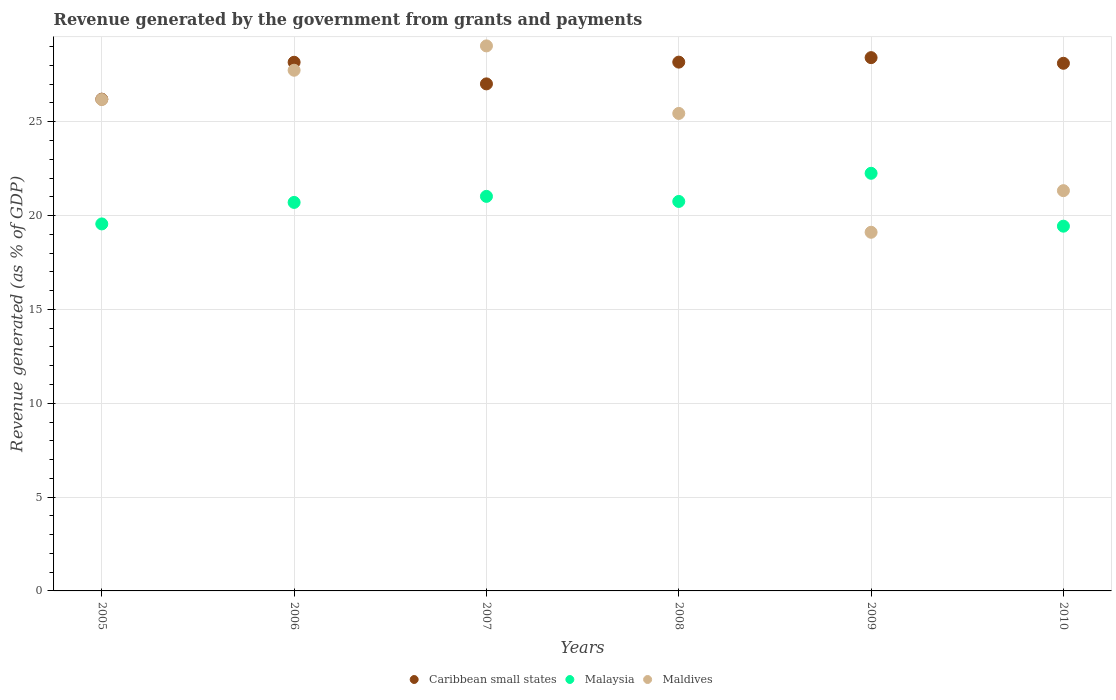How many different coloured dotlines are there?
Your response must be concise. 3. What is the revenue generated by the government in Maldives in 2005?
Provide a succinct answer. 26.19. Across all years, what is the maximum revenue generated by the government in Maldives?
Give a very brief answer. 29.04. Across all years, what is the minimum revenue generated by the government in Caribbean small states?
Make the answer very short. 26.2. In which year was the revenue generated by the government in Malaysia maximum?
Your answer should be very brief. 2009. In which year was the revenue generated by the government in Maldives minimum?
Your answer should be very brief. 2009. What is the total revenue generated by the government in Caribbean small states in the graph?
Offer a terse response. 166.1. What is the difference between the revenue generated by the government in Malaysia in 2006 and that in 2009?
Provide a short and direct response. -1.55. What is the difference between the revenue generated by the government in Maldives in 2010 and the revenue generated by the government in Malaysia in 2008?
Keep it short and to the point. 0.58. What is the average revenue generated by the government in Caribbean small states per year?
Keep it short and to the point. 27.68. In the year 2009, what is the difference between the revenue generated by the government in Maldives and revenue generated by the government in Malaysia?
Give a very brief answer. -3.14. In how many years, is the revenue generated by the government in Maldives greater than 3 %?
Your answer should be compact. 6. What is the ratio of the revenue generated by the government in Maldives in 2005 to that in 2009?
Ensure brevity in your answer.  1.37. Is the revenue generated by the government in Malaysia in 2005 less than that in 2008?
Ensure brevity in your answer.  Yes. Is the difference between the revenue generated by the government in Maldives in 2007 and 2009 greater than the difference between the revenue generated by the government in Malaysia in 2007 and 2009?
Offer a very short reply. Yes. What is the difference between the highest and the second highest revenue generated by the government in Maldives?
Provide a succinct answer. 1.3. What is the difference between the highest and the lowest revenue generated by the government in Caribbean small states?
Your response must be concise. 2.21. Is the sum of the revenue generated by the government in Maldives in 2006 and 2007 greater than the maximum revenue generated by the government in Malaysia across all years?
Make the answer very short. Yes. Is the revenue generated by the government in Caribbean small states strictly less than the revenue generated by the government in Maldives over the years?
Make the answer very short. No. How many dotlines are there?
Keep it short and to the point. 3. What is the difference between two consecutive major ticks on the Y-axis?
Provide a short and direct response. 5. Does the graph contain any zero values?
Ensure brevity in your answer.  No. How many legend labels are there?
Provide a succinct answer. 3. How are the legend labels stacked?
Your response must be concise. Horizontal. What is the title of the graph?
Provide a short and direct response. Revenue generated by the government from grants and payments. Does "Sri Lanka" appear as one of the legend labels in the graph?
Your answer should be very brief. No. What is the label or title of the X-axis?
Ensure brevity in your answer.  Years. What is the label or title of the Y-axis?
Keep it short and to the point. Revenue generated (as % of GDP). What is the Revenue generated (as % of GDP) in Caribbean small states in 2005?
Ensure brevity in your answer.  26.2. What is the Revenue generated (as % of GDP) in Malaysia in 2005?
Keep it short and to the point. 19.56. What is the Revenue generated (as % of GDP) in Maldives in 2005?
Your answer should be very brief. 26.19. What is the Revenue generated (as % of GDP) of Caribbean small states in 2006?
Offer a very short reply. 28.17. What is the Revenue generated (as % of GDP) in Malaysia in 2006?
Keep it short and to the point. 20.7. What is the Revenue generated (as % of GDP) of Maldives in 2006?
Ensure brevity in your answer.  27.75. What is the Revenue generated (as % of GDP) of Caribbean small states in 2007?
Keep it short and to the point. 27.02. What is the Revenue generated (as % of GDP) of Malaysia in 2007?
Offer a terse response. 21.02. What is the Revenue generated (as % of GDP) in Maldives in 2007?
Offer a very short reply. 29.04. What is the Revenue generated (as % of GDP) in Caribbean small states in 2008?
Your answer should be compact. 28.18. What is the Revenue generated (as % of GDP) in Malaysia in 2008?
Keep it short and to the point. 20.75. What is the Revenue generated (as % of GDP) of Maldives in 2008?
Make the answer very short. 25.44. What is the Revenue generated (as % of GDP) in Caribbean small states in 2009?
Your answer should be compact. 28.42. What is the Revenue generated (as % of GDP) of Malaysia in 2009?
Provide a succinct answer. 22.25. What is the Revenue generated (as % of GDP) in Maldives in 2009?
Give a very brief answer. 19.11. What is the Revenue generated (as % of GDP) in Caribbean small states in 2010?
Give a very brief answer. 28.12. What is the Revenue generated (as % of GDP) of Malaysia in 2010?
Your answer should be compact. 19.44. What is the Revenue generated (as % of GDP) of Maldives in 2010?
Offer a very short reply. 21.33. Across all years, what is the maximum Revenue generated (as % of GDP) in Caribbean small states?
Your response must be concise. 28.42. Across all years, what is the maximum Revenue generated (as % of GDP) in Malaysia?
Provide a succinct answer. 22.25. Across all years, what is the maximum Revenue generated (as % of GDP) in Maldives?
Keep it short and to the point. 29.04. Across all years, what is the minimum Revenue generated (as % of GDP) in Caribbean small states?
Offer a very short reply. 26.2. Across all years, what is the minimum Revenue generated (as % of GDP) of Malaysia?
Ensure brevity in your answer.  19.44. Across all years, what is the minimum Revenue generated (as % of GDP) of Maldives?
Keep it short and to the point. 19.11. What is the total Revenue generated (as % of GDP) of Caribbean small states in the graph?
Offer a very short reply. 166.1. What is the total Revenue generated (as % of GDP) of Malaysia in the graph?
Provide a short and direct response. 123.73. What is the total Revenue generated (as % of GDP) in Maldives in the graph?
Your answer should be very brief. 148.86. What is the difference between the Revenue generated (as % of GDP) of Caribbean small states in 2005 and that in 2006?
Ensure brevity in your answer.  -1.97. What is the difference between the Revenue generated (as % of GDP) in Malaysia in 2005 and that in 2006?
Offer a very short reply. -1.15. What is the difference between the Revenue generated (as % of GDP) of Maldives in 2005 and that in 2006?
Provide a succinct answer. -1.56. What is the difference between the Revenue generated (as % of GDP) in Caribbean small states in 2005 and that in 2007?
Offer a very short reply. -0.81. What is the difference between the Revenue generated (as % of GDP) of Malaysia in 2005 and that in 2007?
Provide a succinct answer. -1.47. What is the difference between the Revenue generated (as % of GDP) of Maldives in 2005 and that in 2007?
Make the answer very short. -2.86. What is the difference between the Revenue generated (as % of GDP) in Caribbean small states in 2005 and that in 2008?
Offer a very short reply. -1.97. What is the difference between the Revenue generated (as % of GDP) of Malaysia in 2005 and that in 2008?
Offer a very short reply. -1.2. What is the difference between the Revenue generated (as % of GDP) of Maldives in 2005 and that in 2008?
Make the answer very short. 0.74. What is the difference between the Revenue generated (as % of GDP) of Caribbean small states in 2005 and that in 2009?
Offer a very short reply. -2.21. What is the difference between the Revenue generated (as % of GDP) in Malaysia in 2005 and that in 2009?
Offer a terse response. -2.7. What is the difference between the Revenue generated (as % of GDP) in Maldives in 2005 and that in 2009?
Offer a terse response. 7.07. What is the difference between the Revenue generated (as % of GDP) of Caribbean small states in 2005 and that in 2010?
Provide a succinct answer. -1.91. What is the difference between the Revenue generated (as % of GDP) of Malaysia in 2005 and that in 2010?
Your response must be concise. 0.12. What is the difference between the Revenue generated (as % of GDP) in Maldives in 2005 and that in 2010?
Keep it short and to the point. 4.86. What is the difference between the Revenue generated (as % of GDP) of Caribbean small states in 2006 and that in 2007?
Make the answer very short. 1.15. What is the difference between the Revenue generated (as % of GDP) of Malaysia in 2006 and that in 2007?
Ensure brevity in your answer.  -0.32. What is the difference between the Revenue generated (as % of GDP) of Maldives in 2006 and that in 2007?
Ensure brevity in your answer.  -1.3. What is the difference between the Revenue generated (as % of GDP) in Caribbean small states in 2006 and that in 2008?
Your answer should be compact. -0.01. What is the difference between the Revenue generated (as % of GDP) in Malaysia in 2006 and that in 2008?
Ensure brevity in your answer.  -0.05. What is the difference between the Revenue generated (as % of GDP) of Maldives in 2006 and that in 2008?
Make the answer very short. 2.3. What is the difference between the Revenue generated (as % of GDP) in Caribbean small states in 2006 and that in 2009?
Offer a terse response. -0.25. What is the difference between the Revenue generated (as % of GDP) in Malaysia in 2006 and that in 2009?
Provide a short and direct response. -1.55. What is the difference between the Revenue generated (as % of GDP) in Maldives in 2006 and that in 2009?
Ensure brevity in your answer.  8.63. What is the difference between the Revenue generated (as % of GDP) in Caribbean small states in 2006 and that in 2010?
Your answer should be very brief. 0.05. What is the difference between the Revenue generated (as % of GDP) of Malaysia in 2006 and that in 2010?
Provide a short and direct response. 1.27. What is the difference between the Revenue generated (as % of GDP) in Maldives in 2006 and that in 2010?
Your answer should be compact. 6.42. What is the difference between the Revenue generated (as % of GDP) in Caribbean small states in 2007 and that in 2008?
Your response must be concise. -1.16. What is the difference between the Revenue generated (as % of GDP) of Malaysia in 2007 and that in 2008?
Ensure brevity in your answer.  0.27. What is the difference between the Revenue generated (as % of GDP) of Maldives in 2007 and that in 2008?
Your answer should be compact. 3.6. What is the difference between the Revenue generated (as % of GDP) in Caribbean small states in 2007 and that in 2009?
Provide a succinct answer. -1.4. What is the difference between the Revenue generated (as % of GDP) of Malaysia in 2007 and that in 2009?
Ensure brevity in your answer.  -1.23. What is the difference between the Revenue generated (as % of GDP) of Maldives in 2007 and that in 2009?
Offer a terse response. 9.93. What is the difference between the Revenue generated (as % of GDP) in Caribbean small states in 2007 and that in 2010?
Your response must be concise. -1.1. What is the difference between the Revenue generated (as % of GDP) of Malaysia in 2007 and that in 2010?
Your answer should be very brief. 1.59. What is the difference between the Revenue generated (as % of GDP) of Maldives in 2007 and that in 2010?
Provide a short and direct response. 7.71. What is the difference between the Revenue generated (as % of GDP) of Caribbean small states in 2008 and that in 2009?
Provide a succinct answer. -0.24. What is the difference between the Revenue generated (as % of GDP) of Malaysia in 2008 and that in 2009?
Your answer should be compact. -1.5. What is the difference between the Revenue generated (as % of GDP) in Maldives in 2008 and that in 2009?
Your answer should be compact. 6.33. What is the difference between the Revenue generated (as % of GDP) of Caribbean small states in 2008 and that in 2010?
Your answer should be compact. 0.06. What is the difference between the Revenue generated (as % of GDP) in Malaysia in 2008 and that in 2010?
Your response must be concise. 1.32. What is the difference between the Revenue generated (as % of GDP) of Maldives in 2008 and that in 2010?
Provide a succinct answer. 4.12. What is the difference between the Revenue generated (as % of GDP) of Caribbean small states in 2009 and that in 2010?
Offer a terse response. 0.3. What is the difference between the Revenue generated (as % of GDP) of Malaysia in 2009 and that in 2010?
Offer a terse response. 2.82. What is the difference between the Revenue generated (as % of GDP) of Maldives in 2009 and that in 2010?
Provide a short and direct response. -2.22. What is the difference between the Revenue generated (as % of GDP) of Caribbean small states in 2005 and the Revenue generated (as % of GDP) of Malaysia in 2006?
Keep it short and to the point. 5.5. What is the difference between the Revenue generated (as % of GDP) of Caribbean small states in 2005 and the Revenue generated (as % of GDP) of Maldives in 2006?
Offer a very short reply. -1.54. What is the difference between the Revenue generated (as % of GDP) of Malaysia in 2005 and the Revenue generated (as % of GDP) of Maldives in 2006?
Your response must be concise. -8.19. What is the difference between the Revenue generated (as % of GDP) in Caribbean small states in 2005 and the Revenue generated (as % of GDP) in Malaysia in 2007?
Keep it short and to the point. 5.18. What is the difference between the Revenue generated (as % of GDP) in Caribbean small states in 2005 and the Revenue generated (as % of GDP) in Maldives in 2007?
Your response must be concise. -2.84. What is the difference between the Revenue generated (as % of GDP) of Malaysia in 2005 and the Revenue generated (as % of GDP) of Maldives in 2007?
Your answer should be very brief. -9.49. What is the difference between the Revenue generated (as % of GDP) of Caribbean small states in 2005 and the Revenue generated (as % of GDP) of Malaysia in 2008?
Give a very brief answer. 5.45. What is the difference between the Revenue generated (as % of GDP) of Caribbean small states in 2005 and the Revenue generated (as % of GDP) of Maldives in 2008?
Make the answer very short. 0.76. What is the difference between the Revenue generated (as % of GDP) in Malaysia in 2005 and the Revenue generated (as % of GDP) in Maldives in 2008?
Offer a very short reply. -5.89. What is the difference between the Revenue generated (as % of GDP) of Caribbean small states in 2005 and the Revenue generated (as % of GDP) of Malaysia in 2009?
Offer a terse response. 3.95. What is the difference between the Revenue generated (as % of GDP) of Caribbean small states in 2005 and the Revenue generated (as % of GDP) of Maldives in 2009?
Offer a terse response. 7.09. What is the difference between the Revenue generated (as % of GDP) of Malaysia in 2005 and the Revenue generated (as % of GDP) of Maldives in 2009?
Offer a very short reply. 0.44. What is the difference between the Revenue generated (as % of GDP) in Caribbean small states in 2005 and the Revenue generated (as % of GDP) in Malaysia in 2010?
Make the answer very short. 6.77. What is the difference between the Revenue generated (as % of GDP) in Caribbean small states in 2005 and the Revenue generated (as % of GDP) in Maldives in 2010?
Ensure brevity in your answer.  4.88. What is the difference between the Revenue generated (as % of GDP) of Malaysia in 2005 and the Revenue generated (as % of GDP) of Maldives in 2010?
Your answer should be very brief. -1.77. What is the difference between the Revenue generated (as % of GDP) of Caribbean small states in 2006 and the Revenue generated (as % of GDP) of Malaysia in 2007?
Provide a short and direct response. 7.15. What is the difference between the Revenue generated (as % of GDP) in Caribbean small states in 2006 and the Revenue generated (as % of GDP) in Maldives in 2007?
Make the answer very short. -0.87. What is the difference between the Revenue generated (as % of GDP) in Malaysia in 2006 and the Revenue generated (as % of GDP) in Maldives in 2007?
Provide a succinct answer. -8.34. What is the difference between the Revenue generated (as % of GDP) in Caribbean small states in 2006 and the Revenue generated (as % of GDP) in Malaysia in 2008?
Keep it short and to the point. 7.42. What is the difference between the Revenue generated (as % of GDP) of Caribbean small states in 2006 and the Revenue generated (as % of GDP) of Maldives in 2008?
Ensure brevity in your answer.  2.73. What is the difference between the Revenue generated (as % of GDP) of Malaysia in 2006 and the Revenue generated (as % of GDP) of Maldives in 2008?
Give a very brief answer. -4.74. What is the difference between the Revenue generated (as % of GDP) of Caribbean small states in 2006 and the Revenue generated (as % of GDP) of Malaysia in 2009?
Your answer should be very brief. 5.92. What is the difference between the Revenue generated (as % of GDP) of Caribbean small states in 2006 and the Revenue generated (as % of GDP) of Maldives in 2009?
Keep it short and to the point. 9.06. What is the difference between the Revenue generated (as % of GDP) of Malaysia in 2006 and the Revenue generated (as % of GDP) of Maldives in 2009?
Your answer should be very brief. 1.59. What is the difference between the Revenue generated (as % of GDP) in Caribbean small states in 2006 and the Revenue generated (as % of GDP) in Malaysia in 2010?
Your answer should be very brief. 8.73. What is the difference between the Revenue generated (as % of GDP) in Caribbean small states in 2006 and the Revenue generated (as % of GDP) in Maldives in 2010?
Keep it short and to the point. 6.84. What is the difference between the Revenue generated (as % of GDP) in Malaysia in 2006 and the Revenue generated (as % of GDP) in Maldives in 2010?
Offer a very short reply. -0.63. What is the difference between the Revenue generated (as % of GDP) in Caribbean small states in 2007 and the Revenue generated (as % of GDP) in Malaysia in 2008?
Your response must be concise. 6.26. What is the difference between the Revenue generated (as % of GDP) of Caribbean small states in 2007 and the Revenue generated (as % of GDP) of Maldives in 2008?
Offer a very short reply. 1.57. What is the difference between the Revenue generated (as % of GDP) of Malaysia in 2007 and the Revenue generated (as % of GDP) of Maldives in 2008?
Provide a short and direct response. -4.42. What is the difference between the Revenue generated (as % of GDP) in Caribbean small states in 2007 and the Revenue generated (as % of GDP) in Malaysia in 2009?
Make the answer very short. 4.76. What is the difference between the Revenue generated (as % of GDP) of Caribbean small states in 2007 and the Revenue generated (as % of GDP) of Maldives in 2009?
Provide a short and direct response. 7.91. What is the difference between the Revenue generated (as % of GDP) in Malaysia in 2007 and the Revenue generated (as % of GDP) in Maldives in 2009?
Ensure brevity in your answer.  1.91. What is the difference between the Revenue generated (as % of GDP) in Caribbean small states in 2007 and the Revenue generated (as % of GDP) in Malaysia in 2010?
Keep it short and to the point. 7.58. What is the difference between the Revenue generated (as % of GDP) of Caribbean small states in 2007 and the Revenue generated (as % of GDP) of Maldives in 2010?
Ensure brevity in your answer.  5.69. What is the difference between the Revenue generated (as % of GDP) of Malaysia in 2007 and the Revenue generated (as % of GDP) of Maldives in 2010?
Offer a very short reply. -0.3. What is the difference between the Revenue generated (as % of GDP) in Caribbean small states in 2008 and the Revenue generated (as % of GDP) in Malaysia in 2009?
Offer a very short reply. 5.92. What is the difference between the Revenue generated (as % of GDP) of Caribbean small states in 2008 and the Revenue generated (as % of GDP) of Maldives in 2009?
Offer a very short reply. 9.07. What is the difference between the Revenue generated (as % of GDP) in Malaysia in 2008 and the Revenue generated (as % of GDP) in Maldives in 2009?
Offer a very short reply. 1.64. What is the difference between the Revenue generated (as % of GDP) in Caribbean small states in 2008 and the Revenue generated (as % of GDP) in Malaysia in 2010?
Offer a terse response. 8.74. What is the difference between the Revenue generated (as % of GDP) of Caribbean small states in 2008 and the Revenue generated (as % of GDP) of Maldives in 2010?
Give a very brief answer. 6.85. What is the difference between the Revenue generated (as % of GDP) in Malaysia in 2008 and the Revenue generated (as % of GDP) in Maldives in 2010?
Keep it short and to the point. -0.58. What is the difference between the Revenue generated (as % of GDP) in Caribbean small states in 2009 and the Revenue generated (as % of GDP) in Malaysia in 2010?
Your answer should be compact. 8.98. What is the difference between the Revenue generated (as % of GDP) in Caribbean small states in 2009 and the Revenue generated (as % of GDP) in Maldives in 2010?
Provide a short and direct response. 7.09. What is the difference between the Revenue generated (as % of GDP) in Malaysia in 2009 and the Revenue generated (as % of GDP) in Maldives in 2010?
Provide a succinct answer. 0.93. What is the average Revenue generated (as % of GDP) in Caribbean small states per year?
Provide a short and direct response. 27.68. What is the average Revenue generated (as % of GDP) in Malaysia per year?
Keep it short and to the point. 20.62. What is the average Revenue generated (as % of GDP) of Maldives per year?
Offer a terse response. 24.81. In the year 2005, what is the difference between the Revenue generated (as % of GDP) in Caribbean small states and Revenue generated (as % of GDP) in Malaysia?
Provide a short and direct response. 6.65. In the year 2005, what is the difference between the Revenue generated (as % of GDP) of Caribbean small states and Revenue generated (as % of GDP) of Maldives?
Your answer should be compact. 0.02. In the year 2005, what is the difference between the Revenue generated (as % of GDP) of Malaysia and Revenue generated (as % of GDP) of Maldives?
Offer a terse response. -6.63. In the year 2006, what is the difference between the Revenue generated (as % of GDP) in Caribbean small states and Revenue generated (as % of GDP) in Malaysia?
Provide a short and direct response. 7.47. In the year 2006, what is the difference between the Revenue generated (as % of GDP) in Caribbean small states and Revenue generated (as % of GDP) in Maldives?
Ensure brevity in your answer.  0.42. In the year 2006, what is the difference between the Revenue generated (as % of GDP) of Malaysia and Revenue generated (as % of GDP) of Maldives?
Provide a short and direct response. -7.04. In the year 2007, what is the difference between the Revenue generated (as % of GDP) in Caribbean small states and Revenue generated (as % of GDP) in Malaysia?
Ensure brevity in your answer.  5.99. In the year 2007, what is the difference between the Revenue generated (as % of GDP) in Caribbean small states and Revenue generated (as % of GDP) in Maldives?
Offer a terse response. -2.02. In the year 2007, what is the difference between the Revenue generated (as % of GDP) in Malaysia and Revenue generated (as % of GDP) in Maldives?
Make the answer very short. -8.02. In the year 2008, what is the difference between the Revenue generated (as % of GDP) of Caribbean small states and Revenue generated (as % of GDP) of Malaysia?
Offer a terse response. 7.42. In the year 2008, what is the difference between the Revenue generated (as % of GDP) in Caribbean small states and Revenue generated (as % of GDP) in Maldives?
Keep it short and to the point. 2.73. In the year 2008, what is the difference between the Revenue generated (as % of GDP) in Malaysia and Revenue generated (as % of GDP) in Maldives?
Offer a terse response. -4.69. In the year 2009, what is the difference between the Revenue generated (as % of GDP) in Caribbean small states and Revenue generated (as % of GDP) in Malaysia?
Offer a very short reply. 6.16. In the year 2009, what is the difference between the Revenue generated (as % of GDP) of Caribbean small states and Revenue generated (as % of GDP) of Maldives?
Offer a very short reply. 9.31. In the year 2009, what is the difference between the Revenue generated (as % of GDP) of Malaysia and Revenue generated (as % of GDP) of Maldives?
Your answer should be very brief. 3.14. In the year 2010, what is the difference between the Revenue generated (as % of GDP) in Caribbean small states and Revenue generated (as % of GDP) in Malaysia?
Your answer should be very brief. 8.68. In the year 2010, what is the difference between the Revenue generated (as % of GDP) in Caribbean small states and Revenue generated (as % of GDP) in Maldives?
Your answer should be compact. 6.79. In the year 2010, what is the difference between the Revenue generated (as % of GDP) in Malaysia and Revenue generated (as % of GDP) in Maldives?
Provide a short and direct response. -1.89. What is the ratio of the Revenue generated (as % of GDP) in Caribbean small states in 2005 to that in 2006?
Offer a very short reply. 0.93. What is the ratio of the Revenue generated (as % of GDP) in Malaysia in 2005 to that in 2006?
Ensure brevity in your answer.  0.94. What is the ratio of the Revenue generated (as % of GDP) in Maldives in 2005 to that in 2006?
Your answer should be compact. 0.94. What is the ratio of the Revenue generated (as % of GDP) of Caribbean small states in 2005 to that in 2007?
Make the answer very short. 0.97. What is the ratio of the Revenue generated (as % of GDP) in Malaysia in 2005 to that in 2007?
Your answer should be compact. 0.93. What is the ratio of the Revenue generated (as % of GDP) of Maldives in 2005 to that in 2007?
Provide a short and direct response. 0.9. What is the ratio of the Revenue generated (as % of GDP) in Malaysia in 2005 to that in 2008?
Your answer should be very brief. 0.94. What is the ratio of the Revenue generated (as % of GDP) in Maldives in 2005 to that in 2008?
Your answer should be compact. 1.03. What is the ratio of the Revenue generated (as % of GDP) in Caribbean small states in 2005 to that in 2009?
Ensure brevity in your answer.  0.92. What is the ratio of the Revenue generated (as % of GDP) in Malaysia in 2005 to that in 2009?
Your answer should be compact. 0.88. What is the ratio of the Revenue generated (as % of GDP) of Maldives in 2005 to that in 2009?
Offer a terse response. 1.37. What is the ratio of the Revenue generated (as % of GDP) of Caribbean small states in 2005 to that in 2010?
Give a very brief answer. 0.93. What is the ratio of the Revenue generated (as % of GDP) in Maldives in 2005 to that in 2010?
Make the answer very short. 1.23. What is the ratio of the Revenue generated (as % of GDP) in Caribbean small states in 2006 to that in 2007?
Give a very brief answer. 1.04. What is the ratio of the Revenue generated (as % of GDP) in Malaysia in 2006 to that in 2007?
Give a very brief answer. 0.98. What is the ratio of the Revenue generated (as % of GDP) in Maldives in 2006 to that in 2007?
Offer a very short reply. 0.96. What is the ratio of the Revenue generated (as % of GDP) in Caribbean small states in 2006 to that in 2008?
Provide a short and direct response. 1. What is the ratio of the Revenue generated (as % of GDP) in Maldives in 2006 to that in 2008?
Offer a very short reply. 1.09. What is the ratio of the Revenue generated (as % of GDP) of Caribbean small states in 2006 to that in 2009?
Make the answer very short. 0.99. What is the ratio of the Revenue generated (as % of GDP) of Malaysia in 2006 to that in 2009?
Offer a very short reply. 0.93. What is the ratio of the Revenue generated (as % of GDP) of Maldives in 2006 to that in 2009?
Offer a very short reply. 1.45. What is the ratio of the Revenue generated (as % of GDP) of Malaysia in 2006 to that in 2010?
Your response must be concise. 1.07. What is the ratio of the Revenue generated (as % of GDP) in Maldives in 2006 to that in 2010?
Keep it short and to the point. 1.3. What is the ratio of the Revenue generated (as % of GDP) in Caribbean small states in 2007 to that in 2008?
Your answer should be very brief. 0.96. What is the ratio of the Revenue generated (as % of GDP) of Malaysia in 2007 to that in 2008?
Provide a succinct answer. 1.01. What is the ratio of the Revenue generated (as % of GDP) in Maldives in 2007 to that in 2008?
Keep it short and to the point. 1.14. What is the ratio of the Revenue generated (as % of GDP) in Caribbean small states in 2007 to that in 2009?
Offer a very short reply. 0.95. What is the ratio of the Revenue generated (as % of GDP) in Malaysia in 2007 to that in 2009?
Your answer should be compact. 0.94. What is the ratio of the Revenue generated (as % of GDP) in Maldives in 2007 to that in 2009?
Offer a terse response. 1.52. What is the ratio of the Revenue generated (as % of GDP) in Malaysia in 2007 to that in 2010?
Make the answer very short. 1.08. What is the ratio of the Revenue generated (as % of GDP) of Maldives in 2007 to that in 2010?
Your answer should be very brief. 1.36. What is the ratio of the Revenue generated (as % of GDP) in Malaysia in 2008 to that in 2009?
Offer a very short reply. 0.93. What is the ratio of the Revenue generated (as % of GDP) of Maldives in 2008 to that in 2009?
Make the answer very short. 1.33. What is the ratio of the Revenue generated (as % of GDP) in Caribbean small states in 2008 to that in 2010?
Keep it short and to the point. 1. What is the ratio of the Revenue generated (as % of GDP) of Malaysia in 2008 to that in 2010?
Give a very brief answer. 1.07. What is the ratio of the Revenue generated (as % of GDP) in Maldives in 2008 to that in 2010?
Give a very brief answer. 1.19. What is the ratio of the Revenue generated (as % of GDP) of Caribbean small states in 2009 to that in 2010?
Ensure brevity in your answer.  1.01. What is the ratio of the Revenue generated (as % of GDP) in Malaysia in 2009 to that in 2010?
Provide a succinct answer. 1.15. What is the ratio of the Revenue generated (as % of GDP) of Maldives in 2009 to that in 2010?
Give a very brief answer. 0.9. What is the difference between the highest and the second highest Revenue generated (as % of GDP) of Caribbean small states?
Provide a succinct answer. 0.24. What is the difference between the highest and the second highest Revenue generated (as % of GDP) of Malaysia?
Your answer should be very brief. 1.23. What is the difference between the highest and the second highest Revenue generated (as % of GDP) in Maldives?
Your answer should be compact. 1.3. What is the difference between the highest and the lowest Revenue generated (as % of GDP) in Caribbean small states?
Offer a terse response. 2.21. What is the difference between the highest and the lowest Revenue generated (as % of GDP) of Malaysia?
Provide a short and direct response. 2.82. What is the difference between the highest and the lowest Revenue generated (as % of GDP) of Maldives?
Your answer should be very brief. 9.93. 